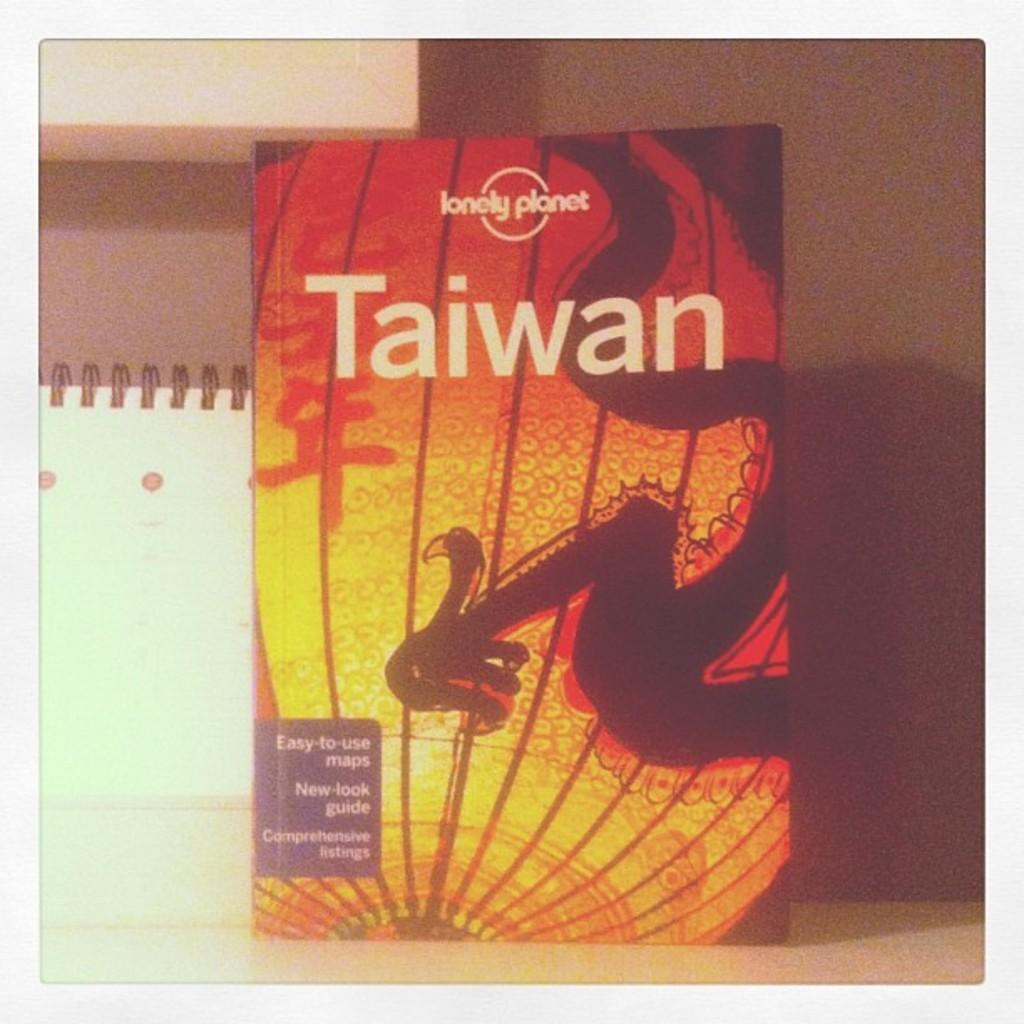What object can be seen in the image? There is a book in the image. What can be seen in the background of the image? There is a wall visible in the background of the image. What type of van is parked next to the wall in the image? There is no van present in the image; it only features a book and a wall in the background. 